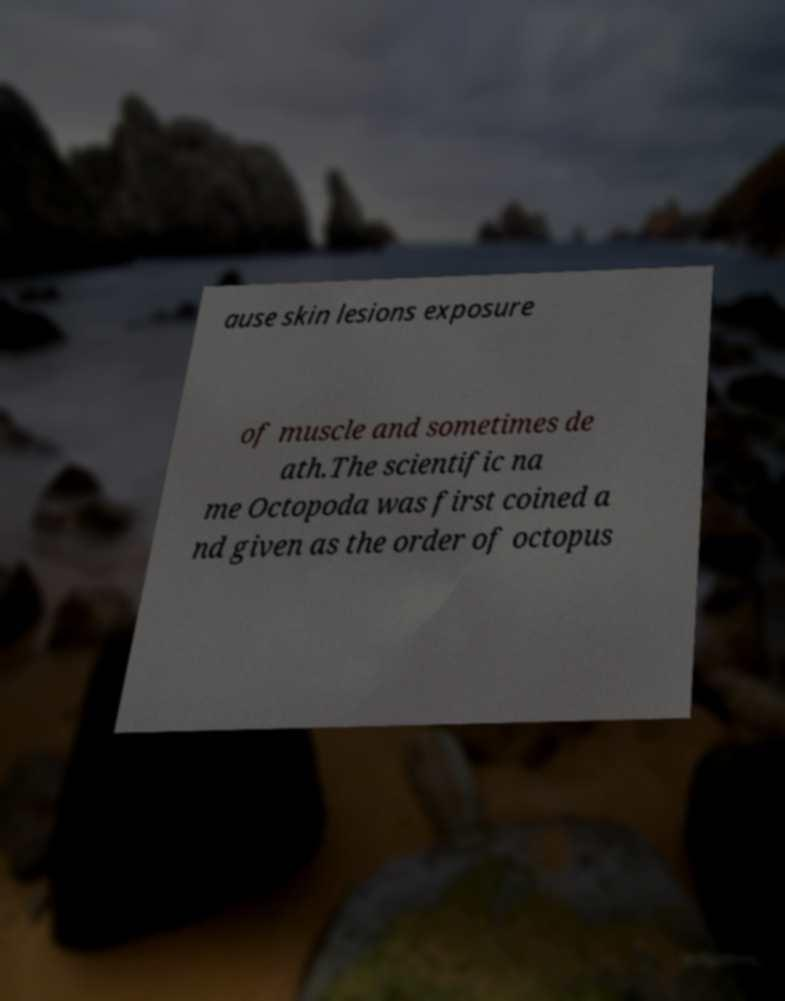For documentation purposes, I need the text within this image transcribed. Could you provide that? ause skin lesions exposure of muscle and sometimes de ath.The scientific na me Octopoda was first coined a nd given as the order of octopus 